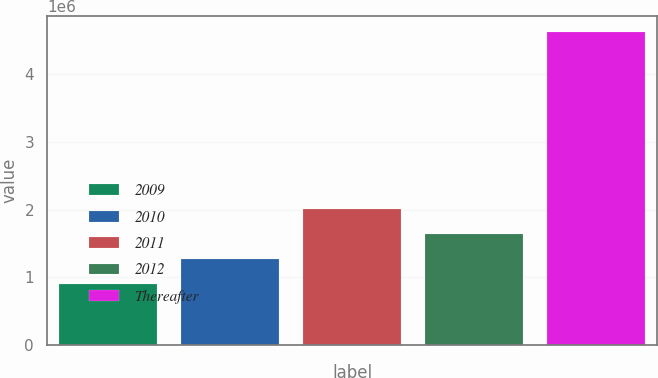Convert chart. <chart><loc_0><loc_0><loc_500><loc_500><bar_chart><fcel>2009<fcel>2010<fcel>2011<fcel>2012<fcel>Thereafter<nl><fcel>896692<fcel>1.26992e+06<fcel>2.01638e+06<fcel>1.64315e+06<fcel>4.629e+06<nl></chart> 